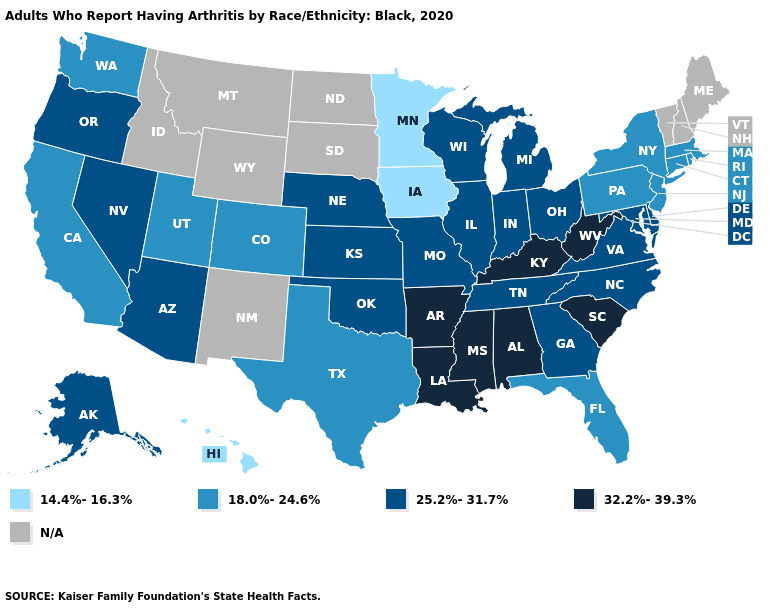What is the lowest value in states that border New Hampshire?
Answer briefly. 18.0%-24.6%. What is the highest value in the USA?
Concise answer only. 32.2%-39.3%. What is the value of South Dakota?
Concise answer only. N/A. What is the value of Alabama?
Quick response, please. 32.2%-39.3%. Which states have the lowest value in the Northeast?
Write a very short answer. Connecticut, Massachusetts, New Jersey, New York, Pennsylvania, Rhode Island. Name the states that have a value in the range 14.4%-16.3%?
Write a very short answer. Hawaii, Iowa, Minnesota. What is the value of California?
Be succinct. 18.0%-24.6%. What is the highest value in the Northeast ?
Quick response, please. 18.0%-24.6%. What is the value of Montana?
Keep it brief. N/A. What is the value of Minnesota?
Write a very short answer. 14.4%-16.3%. Name the states that have a value in the range 18.0%-24.6%?
Answer briefly. California, Colorado, Connecticut, Florida, Massachusetts, New Jersey, New York, Pennsylvania, Rhode Island, Texas, Utah, Washington. Is the legend a continuous bar?
Concise answer only. No. Does Wisconsin have the highest value in the MidWest?
Be succinct. Yes. Name the states that have a value in the range 18.0%-24.6%?
Write a very short answer. California, Colorado, Connecticut, Florida, Massachusetts, New Jersey, New York, Pennsylvania, Rhode Island, Texas, Utah, Washington. What is the value of Hawaii?
Concise answer only. 14.4%-16.3%. 